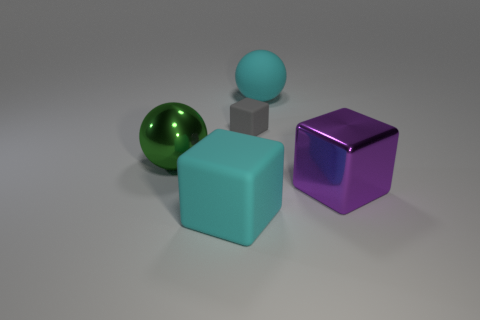Subtract all big rubber cubes. How many cubes are left? 2 Subtract 1 cubes. How many cubes are left? 2 Subtract all spheres. How many objects are left? 3 Add 5 small gray matte objects. How many objects exist? 10 Subtract 0 blue balls. How many objects are left? 5 Subtract all brown cubes. Subtract all green balls. How many cubes are left? 3 Subtract all red rubber blocks. Subtract all tiny rubber things. How many objects are left? 4 Add 2 small gray objects. How many small gray objects are left? 3 Add 4 small gray matte things. How many small gray matte things exist? 5 